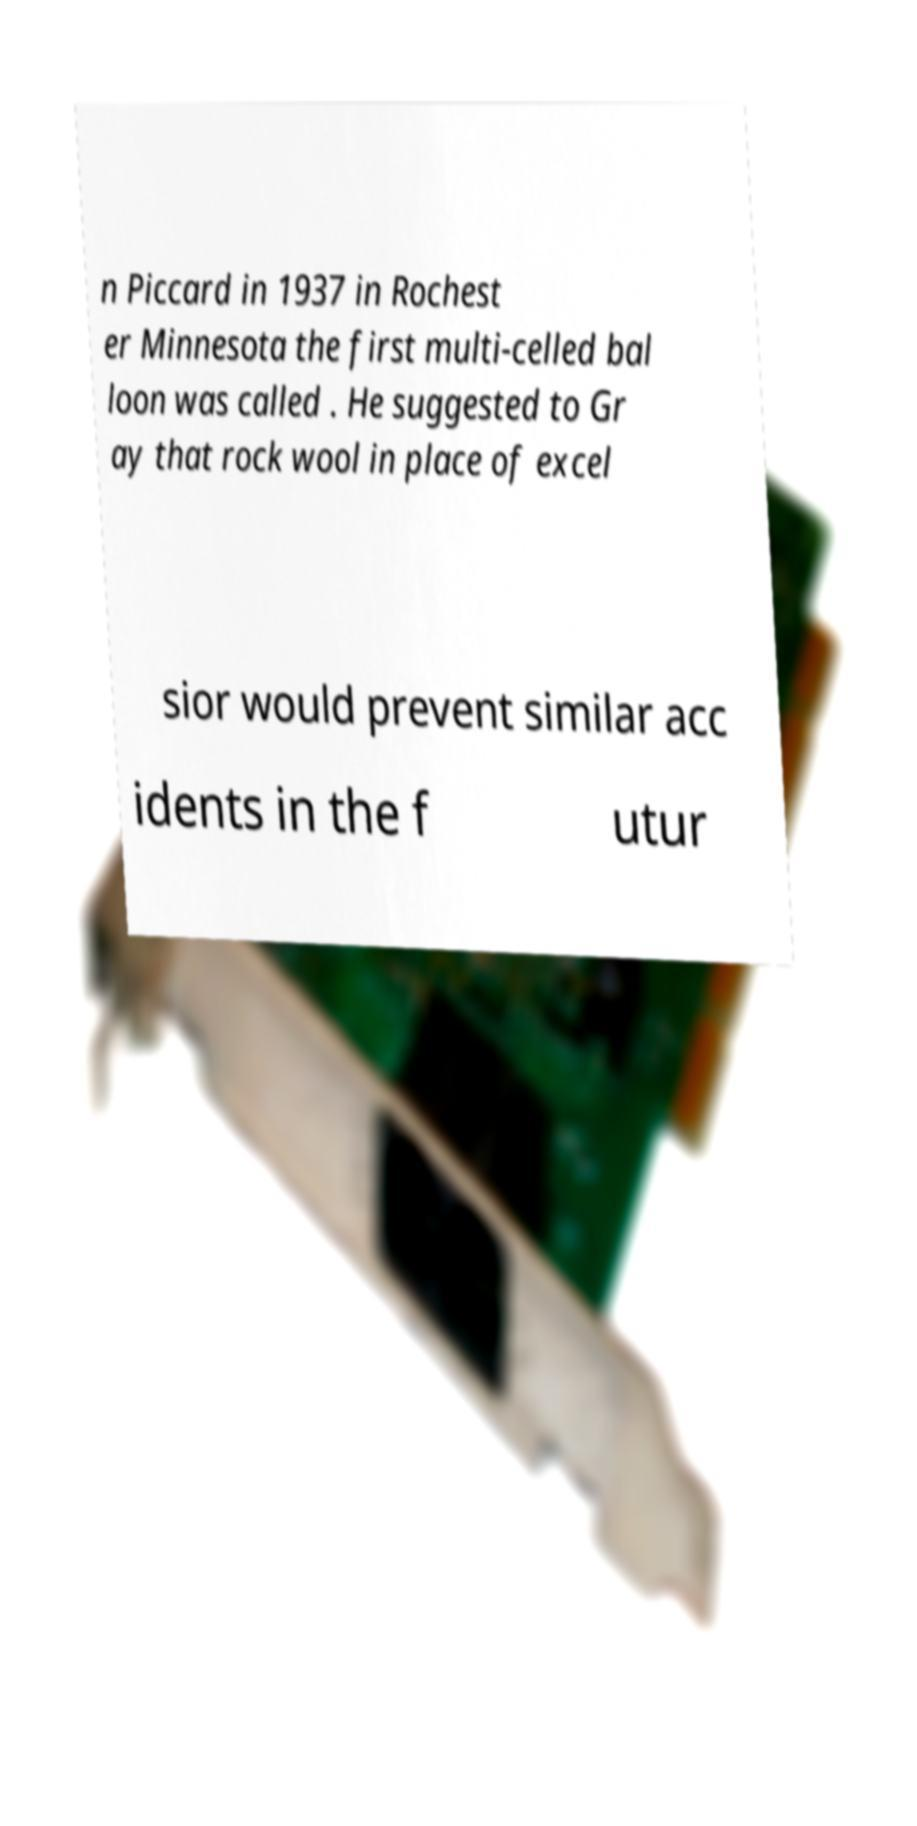Could you assist in decoding the text presented in this image and type it out clearly? n Piccard in 1937 in Rochest er Minnesota the first multi-celled bal loon was called . He suggested to Gr ay that rock wool in place of excel sior would prevent similar acc idents in the f utur 